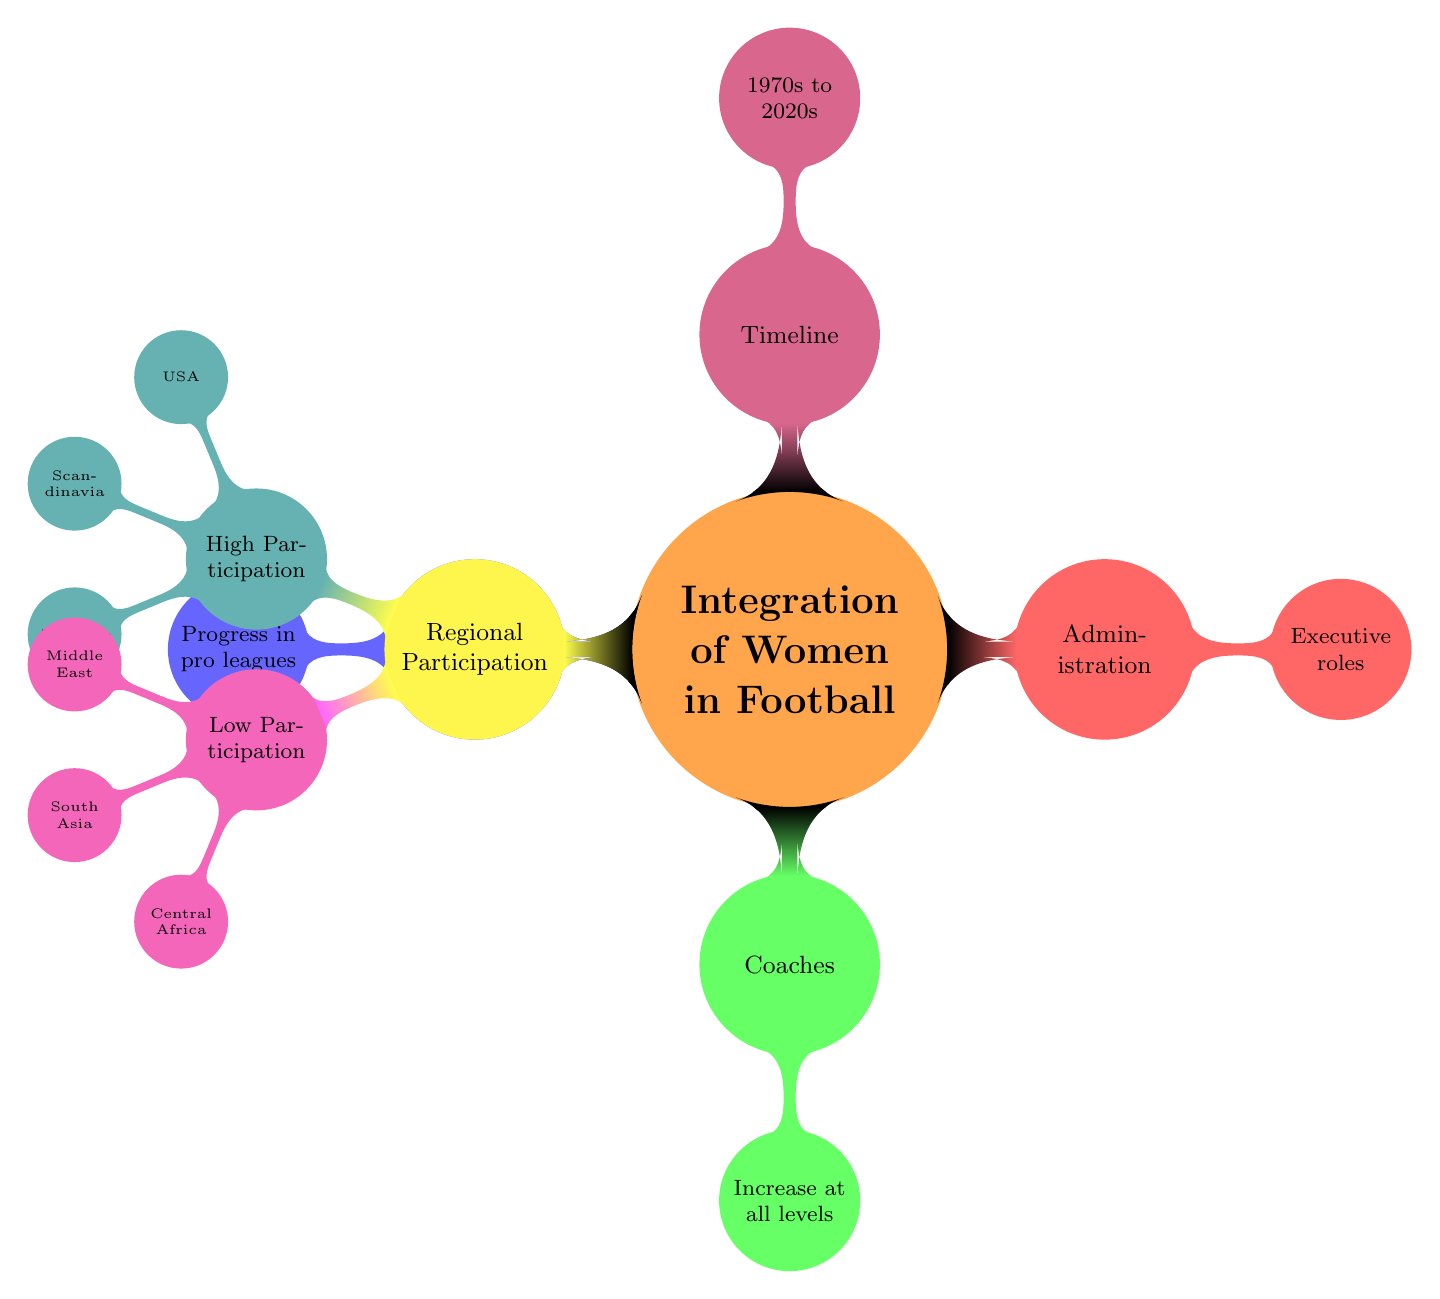What are the main roles for women in football represented in the diagram? The diagram lists three main roles: Players, Coaches, and Administration. Each role is visually distinct, representing different areas where women are integrated into football.
Answer: Players, Coaches, Administration Which region shows high participation of women in football? The diagram specifies three regions with high participation: USA, Scandinavia, and Australia. These regions are highlighted in teal, indicating their notable levels of involvement.
Answer: USA, Scandinavia, Australia What decade range is covered in the timeline of the diagram? The timeline indicates the period from the 1970s to the 2020s. This is represented as a single node labeled "Timeline," which captures the historical aspect of women's integration into football.
Answer: 1970s to 2020s How are the roles of coaches described in the diagram? Coaches are described as having an increase at all levels. This indicates a growing recognition of women's capabilities in coaching roles throughout different tiers of football.
Answer: Increase at all levels Name one region where women have low participation in football. The diagram highlights three regions with low participation: Middle East, South Asia, and Central Africa. Any of these regions can be used as an answer.
Answer: Middle East What color denotes the concept 'Administration' in the diagram? The concept of 'Administration' is represented by the color red in the diagram. This color coding helps visually distinguish the different roles of women in football.
Answer: Red Which role has a specific mention of 'Executive roles'? The role specifically mentioned with 'Executive roles' is Administration. This highlights women's involvement in leadership and decision-making positions within football organizations.
Answer: Administration In which part of the diagram would you find information about players? Information about players is found in the blue section of the diagram, which details their progress in professional leagues, indicating the advancements made by women in this role.
Answer: Players 